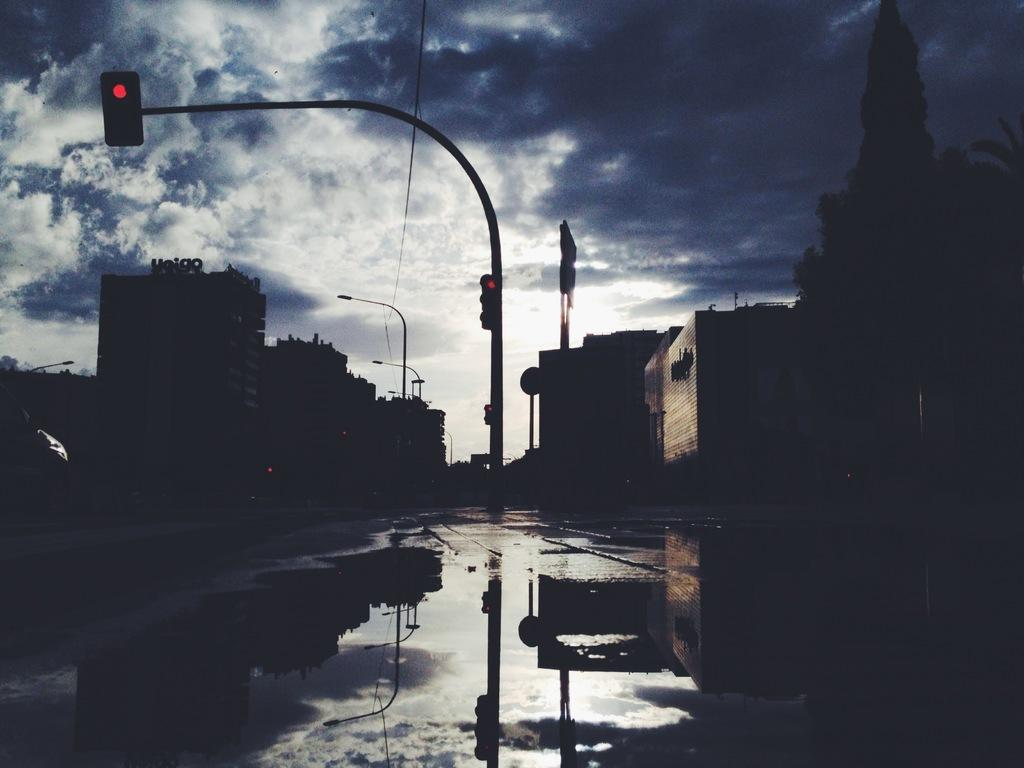What is located in the center of the image? There are traffic signals on a pole in the center of the image. What can be seen in the background of the image? There is a group of buildings in the background. How would you describe the sky in the image? The sky is cloudy in the image. What is visible in the foreground of the image? There is water visible in the foreground. What type of war is being fought in the image? There is no war depicted in the image; it features traffic signals, buildings, a cloudy sky, and water. How does the boy's stomach feel in the image? There is no boy present in the image, so it is impossible to determine how his stomach feels. 